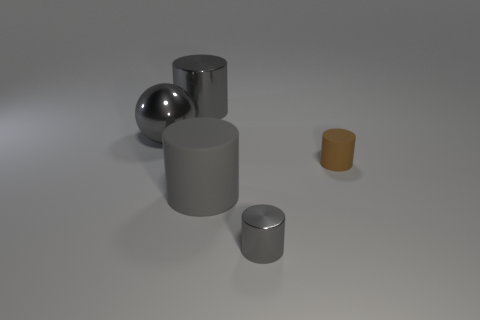The matte thing that is to the left of the tiny cylinder that is behind the small shiny thing is what color?
Your answer should be compact. Gray. Does the metal cylinder that is behind the brown matte cylinder have the same color as the big rubber object?
Offer a very short reply. Yes. Do the brown rubber object and the gray matte thing have the same size?
Provide a short and direct response. No. The object that is the same size as the brown cylinder is what shape?
Make the answer very short. Cylinder. There is a cylinder that is behind the ball; is its size the same as the tiny gray metal cylinder?
Provide a short and direct response. No. There is a gray cylinder that is the same size as the gray rubber object; what is its material?
Offer a very short reply. Metal. Is there a small gray metallic object that is behind the metallic thing in front of the large gray cylinder in front of the gray ball?
Your answer should be compact. No. Is there any other thing that has the same shape as the small brown object?
Offer a very short reply. Yes. Do the cylinder behind the small matte cylinder and the tiny cylinder that is to the left of the small brown cylinder have the same color?
Provide a short and direct response. Yes. Are any large yellow metallic blocks visible?
Your answer should be very brief. No. 